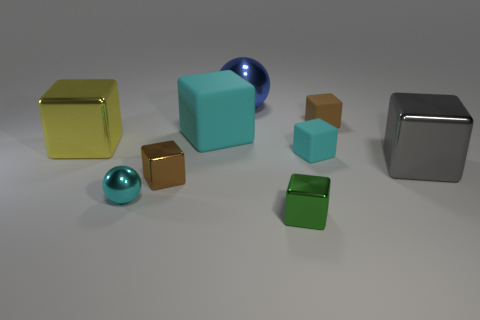Subtract all gray metal cubes. How many cubes are left? 6 Subtract all gray cubes. How many cubes are left? 6 Subtract all gray cubes. Subtract all cyan cylinders. How many cubes are left? 6 Add 1 small cyan rubber blocks. How many objects exist? 10 Subtract all spheres. How many objects are left? 7 Add 3 big cyan objects. How many big cyan objects exist? 4 Subtract 0 gray cylinders. How many objects are left? 9 Subtract all small cyan things. Subtract all tiny gray rubber balls. How many objects are left? 7 Add 4 tiny matte things. How many tiny matte things are left? 6 